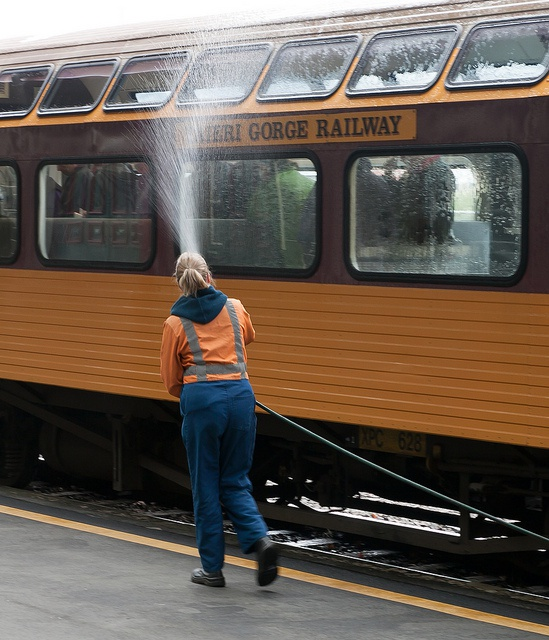Describe the objects in this image and their specific colors. I can see train in white, black, brown, gray, and darkgray tones, people in white, black, navy, gray, and brown tones, and people in white, black, gray, and purple tones in this image. 